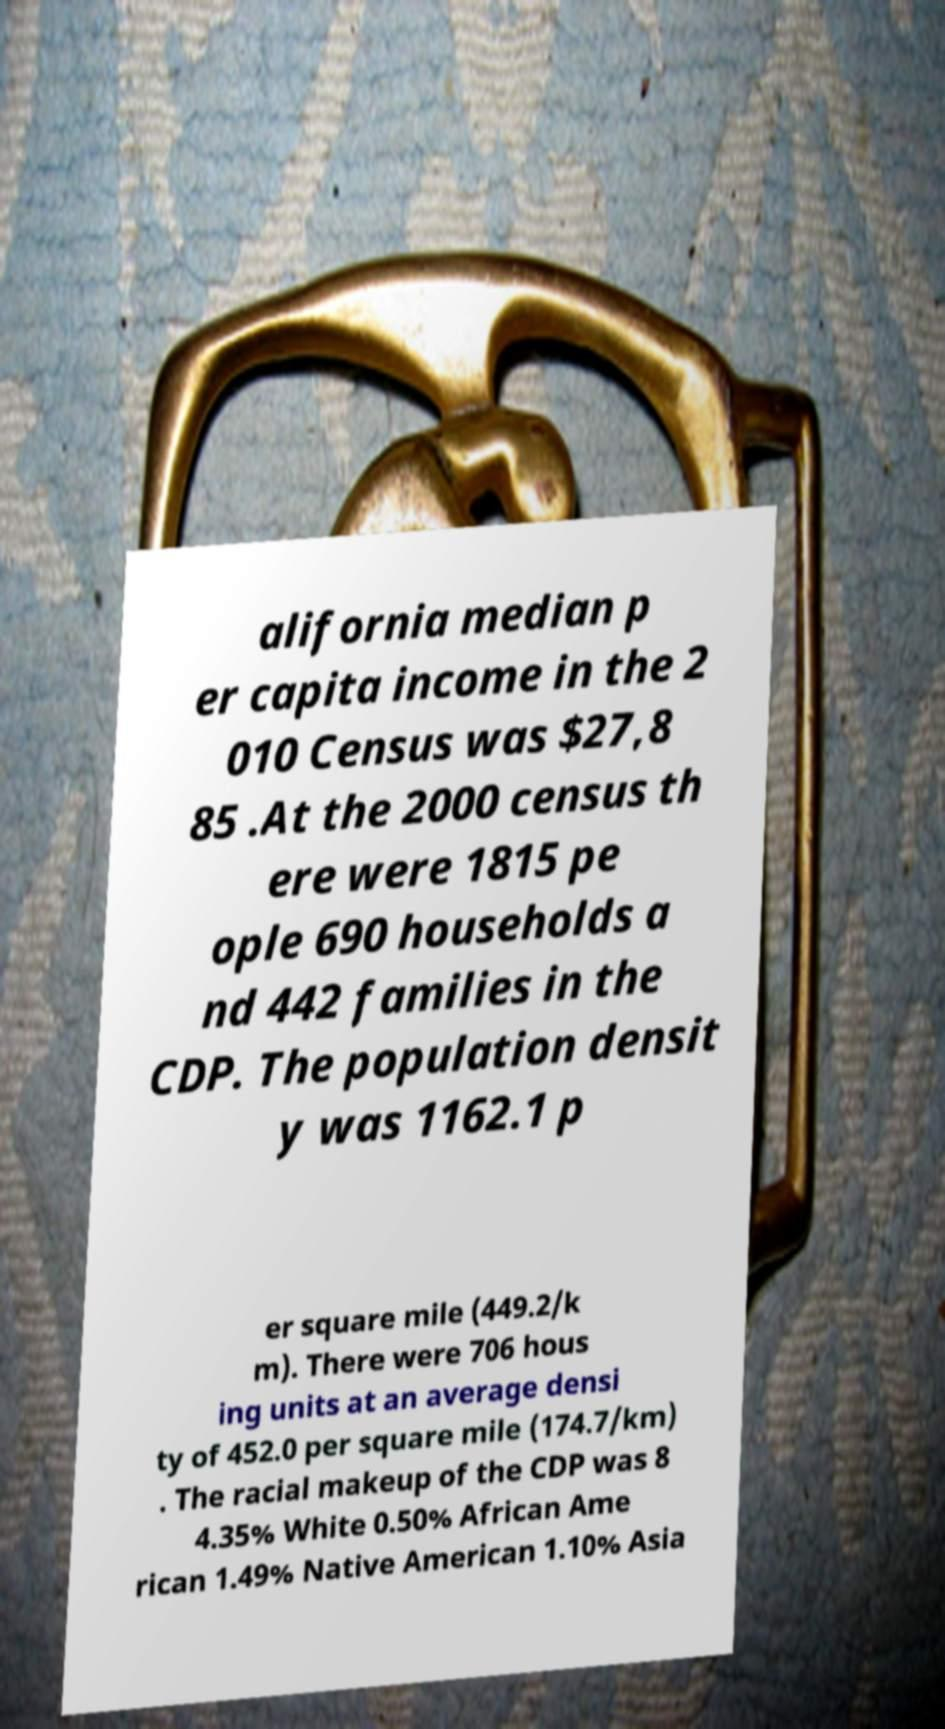Can you read and provide the text displayed in the image?This photo seems to have some interesting text. Can you extract and type it out for me? alifornia median p er capita income in the 2 010 Census was $27,8 85 .At the 2000 census th ere were 1815 pe ople 690 households a nd 442 families in the CDP. The population densit y was 1162.1 p er square mile (449.2/k m). There were 706 hous ing units at an average densi ty of 452.0 per square mile (174.7/km) . The racial makeup of the CDP was 8 4.35% White 0.50% African Ame rican 1.49% Native American 1.10% Asia 